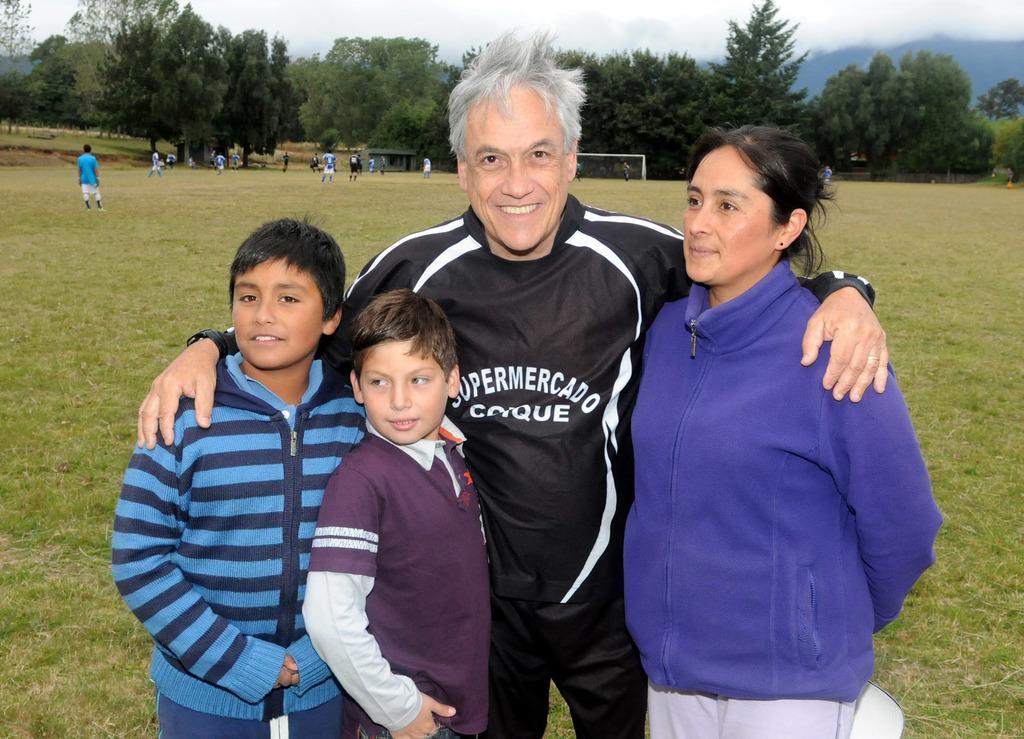In one or two sentences, can you explain what this image depicts? In this image we can see a group of people standing on the ground. We can also see the grass, some people and a goal post on the ground. On the backside we can see a group of trees, the hills and the sky which looks cloudy. 